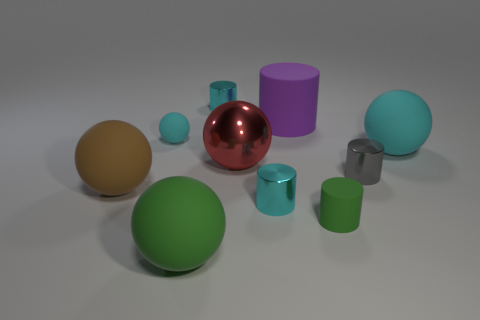Can you describe the lighting and the atmosphere suggested by the image? The lighting in the image is soft and diffused, casting gentle shadows and highlighting the objects with a subtle glow. This creates a calm and serene atmosphere, almost like a staged product photo or a 3D rendering intended to showcase the objects clearly without any harsh shadows or bright spots. 